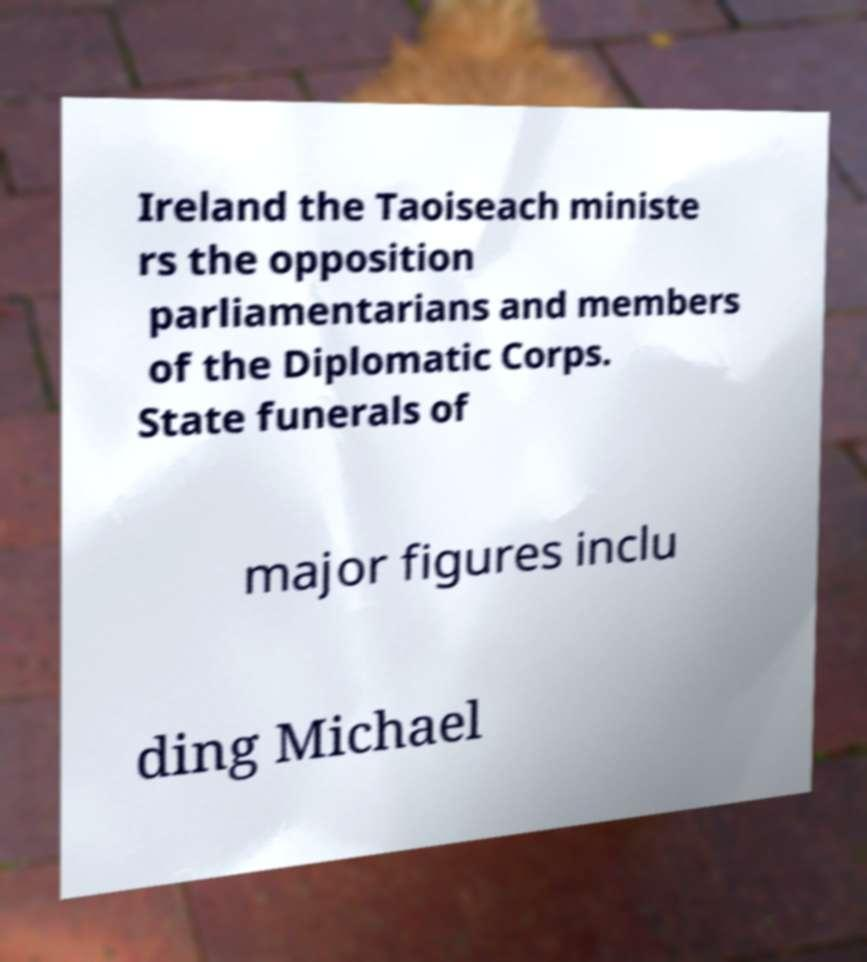Can you accurately transcribe the text from the provided image for me? Ireland the Taoiseach ministe rs the opposition parliamentarians and members of the Diplomatic Corps. State funerals of major figures inclu ding Michael 